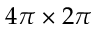<formula> <loc_0><loc_0><loc_500><loc_500>4 \pi \times 2 \pi</formula> 